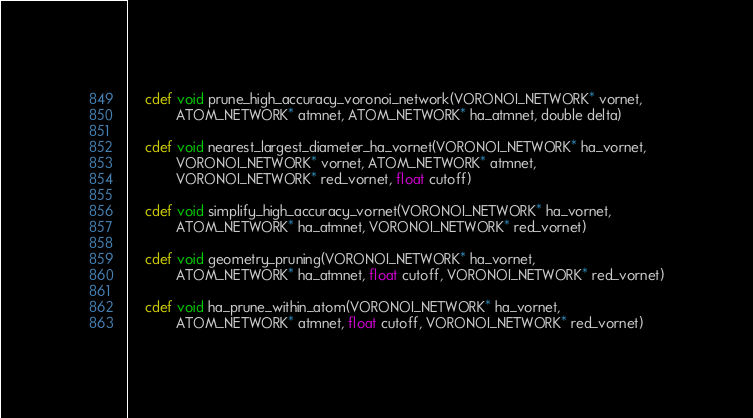<code> <loc_0><loc_0><loc_500><loc_500><_Cython_>
    cdef void prune_high_accuracy_voronoi_network(VORONOI_NETWORK* vornet, 
            ATOM_NETWORK* atmnet, ATOM_NETWORK* ha_atmnet, double delta)

    cdef void nearest_largest_diameter_ha_vornet(VORONOI_NETWORK* ha_vornet,
            VORONOI_NETWORK* vornet, ATOM_NETWORK* atmnet, 
            VORONOI_NETWORK* red_vornet, float cutoff)

    cdef void simplify_high_accuracy_vornet(VORONOI_NETWORK* ha_vornet,
            ATOM_NETWORK* ha_atmnet, VORONOI_NETWORK* red_vornet)

    cdef void geometry_pruning(VORONOI_NETWORK* ha_vornet, 
            ATOM_NETWORK* ha_atmnet, float cutoff, VORONOI_NETWORK* red_vornet)

    cdef void ha_prune_within_atom(VORONOI_NETWORK* ha_vornet, 
            ATOM_NETWORK* atmnet, float cutoff, VORONOI_NETWORK* red_vornet)
</code> 